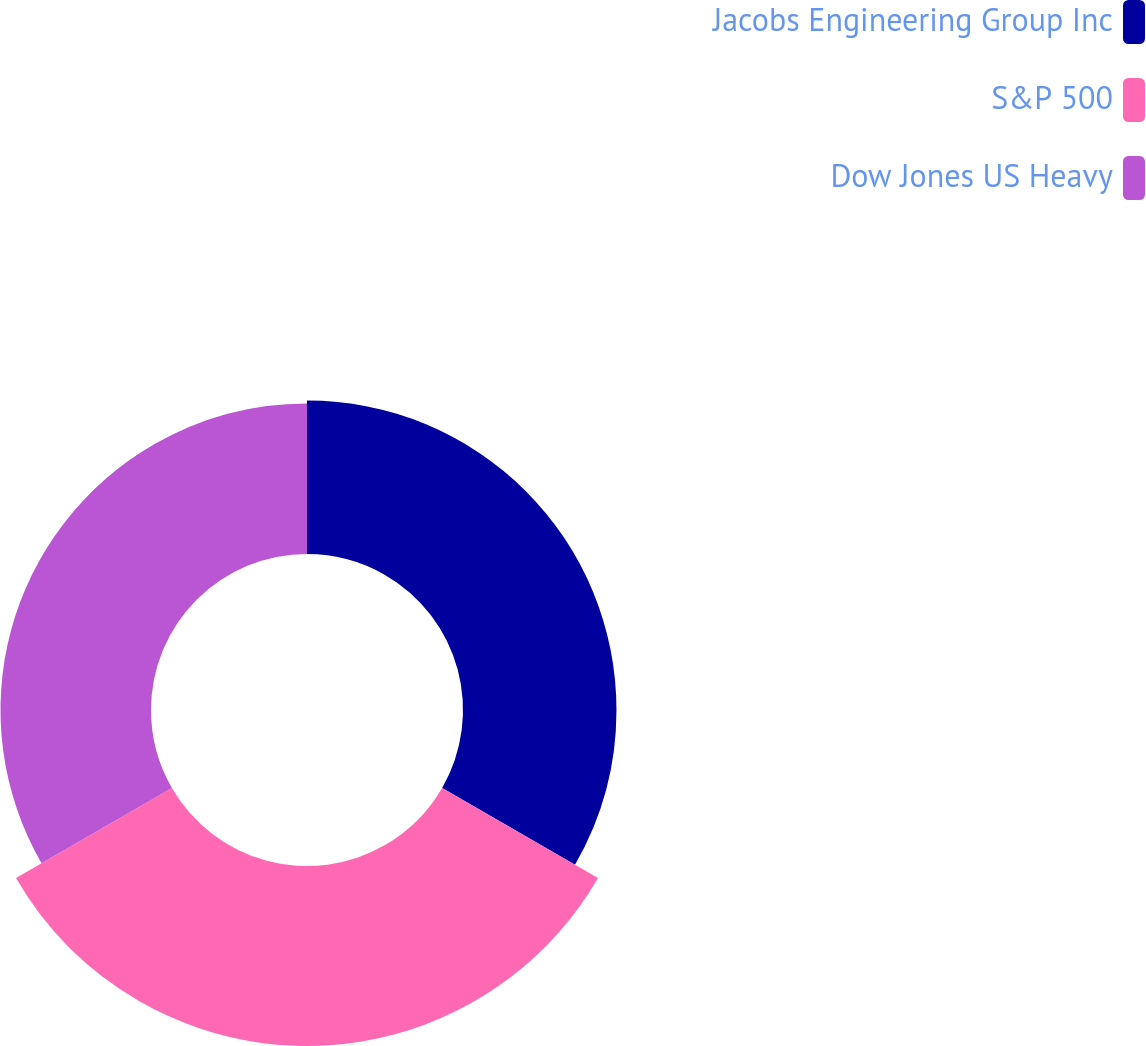<chart> <loc_0><loc_0><loc_500><loc_500><pie_chart><fcel>Jacobs Engineering Group Inc<fcel>S&P 500<fcel>Dow Jones US Heavy<nl><fcel>31.71%<fcel>37.19%<fcel>31.1%<nl></chart> 